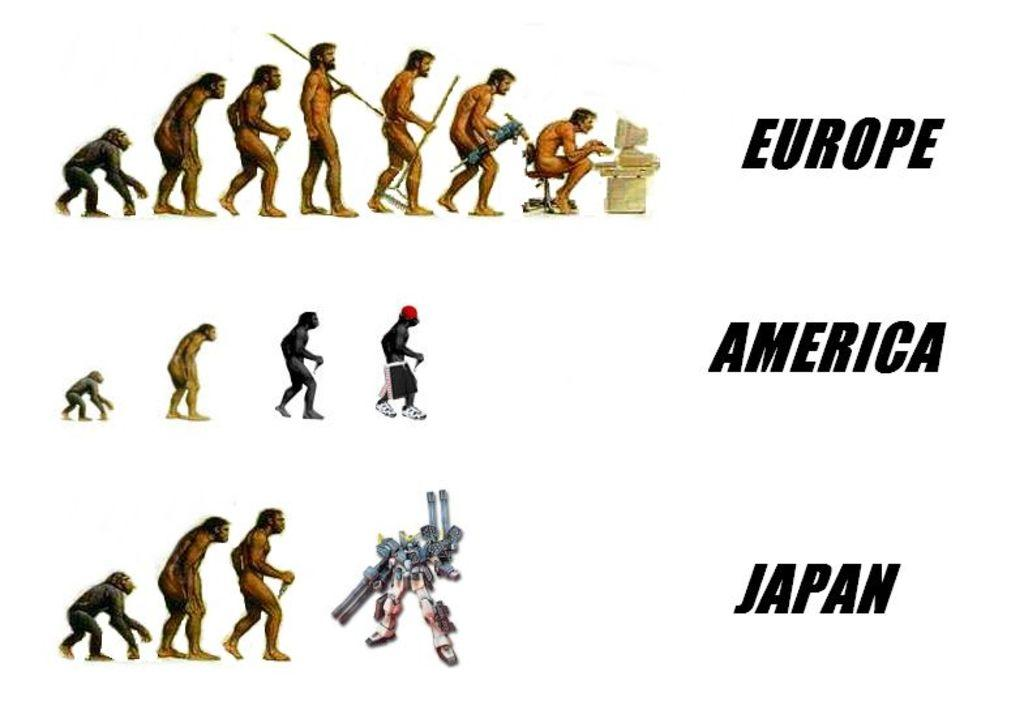What types of subjects are depicted in the image? There are ape stages and a robot in the image. What is the nature of the text in the image? The text in the image is edited. What color is the background of the image? The background of the image is white. Can you see a scarf being worn by the robot in the image? There is no scarf present in the image, and the robot is not wearing any clothing. 